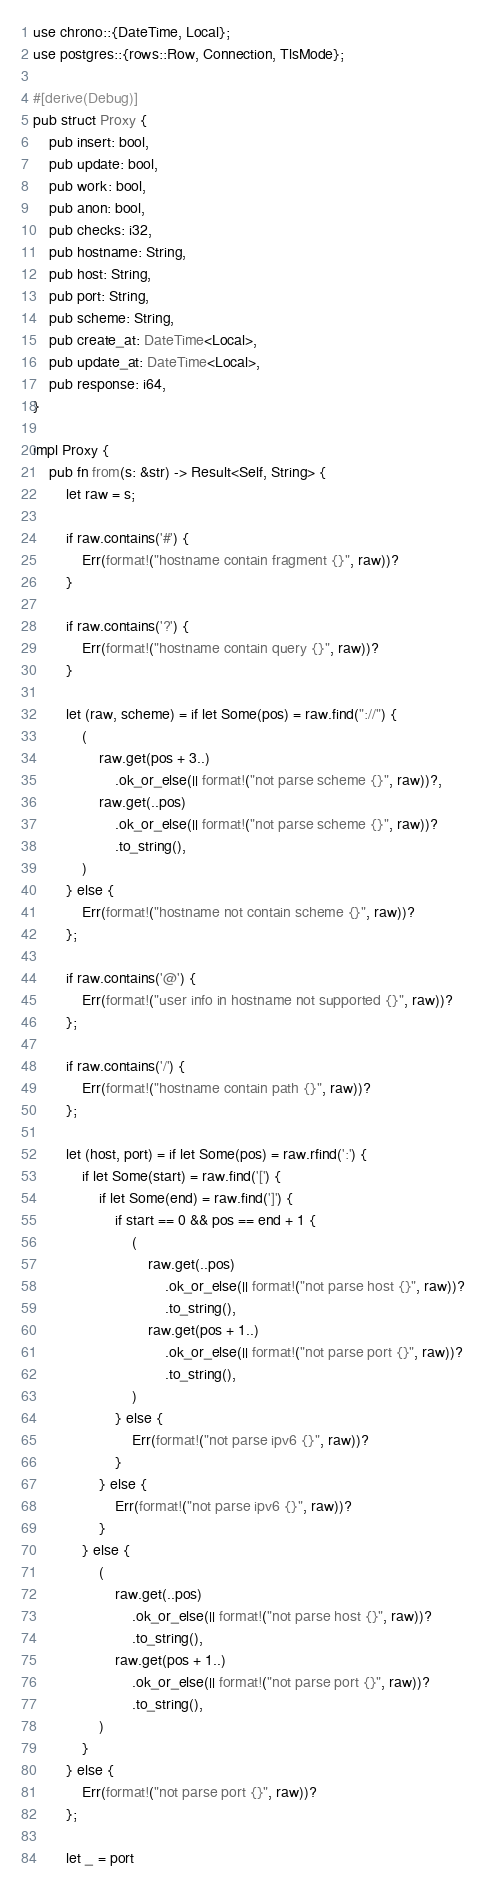Convert code to text. <code><loc_0><loc_0><loc_500><loc_500><_Rust_>use chrono::{DateTime, Local};
use postgres::{rows::Row, Connection, TlsMode};

#[derive(Debug)]
pub struct Proxy {
    pub insert: bool,
    pub update: bool,
    pub work: bool,
    pub anon: bool,
    pub checks: i32,
    pub hostname: String,
    pub host: String,
    pub port: String,
    pub scheme: String,
    pub create_at: DateTime<Local>,
    pub update_at: DateTime<Local>,
    pub response: i64,
}

impl Proxy {
    pub fn from(s: &str) -> Result<Self, String> {
        let raw = s;

        if raw.contains('#') {
            Err(format!("hostname contain fragment {}", raw))?
        }

        if raw.contains('?') {
            Err(format!("hostname contain query {}", raw))?
        }

        let (raw, scheme) = if let Some(pos) = raw.find("://") {
            (
                raw.get(pos + 3..)
                    .ok_or_else(|| format!("not parse scheme {}", raw))?,
                raw.get(..pos)
                    .ok_or_else(|| format!("not parse scheme {}", raw))?
                    .to_string(),
            )
        } else {
            Err(format!("hostname not contain scheme {}", raw))?
        };

        if raw.contains('@') {
            Err(format!("user info in hostname not supported {}", raw))?
        };

        if raw.contains('/') {
            Err(format!("hostname contain path {}", raw))?
        };

        let (host, port) = if let Some(pos) = raw.rfind(':') {
            if let Some(start) = raw.find('[') {
                if let Some(end) = raw.find(']') {
                    if start == 0 && pos == end + 1 {
                        (
                            raw.get(..pos)
                                .ok_or_else(|| format!("not parse host {}", raw))?
                                .to_string(),
                            raw.get(pos + 1..)
                                .ok_or_else(|| format!("not parse port {}", raw))?
                                .to_string(),
                        )
                    } else {
                        Err(format!("not parse ipv6 {}", raw))?
                    }
                } else {
                    Err(format!("not parse ipv6 {}", raw))?
                }
            } else {
                (
                    raw.get(..pos)
                        .ok_or_else(|| format!("not parse host {}", raw))?
                        .to_string(),
                    raw.get(pos + 1..)
                        .ok_or_else(|| format!("not parse port {}", raw))?
                        .to_string(),
                )
            }
        } else {
            Err(format!("not parse port {}", raw))?
        };

        let _ = port</code> 